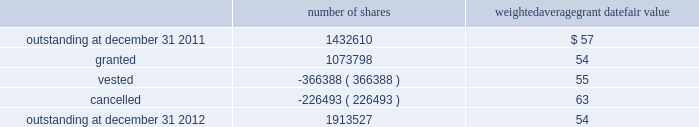The weighted average grant date fair value of options granted during 2012 , 2011 , and 2010 was $ 13 , $ 19 and $ 20 per share , respectively .
The total intrinsic value of options exercised during the years ended december 31 , 2012 , 2011 and 2010 , was $ 19.0 million , $ 4.2 million and $ 15.6 million , respectively .
In 2012 , the company granted 931340 shares of restricted class a common stock and 4048 shares of restricted stock units .
Restricted common stock and restricted stock units generally have a vesting period of 2 to 4 years .
The fair value related to these grants was $ 54.5 million , which is recognized as compensation expense on an accelerated basis over the vesting period .
Beginning with restricted stock grants in september 2010 , dividends are accrued on restricted class a common stock and restricted stock units and are paid once the restricted stock vests .
In 2012 , the company also granted 138410 performance shares .
The fair value related to these grants was $ 7.7 million , which is recognized as compensation expense on an accelerated and straight-lined basis over the vesting period .
The vesting of these shares is contingent on meeting stated performance or market conditions .
The table summarizes restricted stock , restricted stock units , and performance shares activity for 2012 : number of shares weighted average grant date fair value outstanding at december 31 , 2011 .
1432610 $ 57 .
Outstanding at december 31 , 2012 .
1913527 54 the total fair value of restricted stock , restricted stock units , and performance shares that vested during the years ended december 31 , 2012 , 2011 and 2010 , was $ 20.9 million , $ 11.6 million and $ 10.3 million , respectively .
Eligible employees may acquire shares of class a common stock using after-tax payroll deductions made during consecutive offering periods of approximately six months in duration .
Shares are purchased at the end of each offering period at a price of 90% ( 90 % ) of the closing price of the class a common stock as reported on the nasdaq global select market .
Compensation expense is recognized on the dates of purchase for the discount from the closing price .
In 2012 , 2011 and 2010 , a total of 27768 , 32085 and 21855 shares , respectively , of class a common stock were issued to participating employees .
These shares are subject to a six-month holding period .
Annual expense of $ 0.1 million , $ 0.2 million and $ 0.1 million for the purchase discount was recognized in 2012 , 2011 and 2010 , respectively .
Non-executive directors receive an annual award of class a common stock with a value equal to $ 75000 .
Non-executive directors may also elect to receive some or all of the cash portion of their annual stipend , up to $ 25000 , in shares of stock based on the closing price at the date of distribution .
As a result , 40260 , 40585 and 37350 shares of class a common stock were issued to non-executive directors during 2012 , 2011 and 2010 , respectively .
These shares are not subject to any vesting restrictions .
Expense of $ 2.2 million , $ 2.1 million and $ 2.4 million related to these stock-based payments was recognized for the years ended december 31 , 2012 , 2011 and 2010 , respectively .
19 .
Fair value measurements in general , the company uses quoted prices in active markets for identical assets to determine the fair value of marketable securities and equity investments .
Level 1 assets generally include u.s .
Treasury securities , equity securities listed in active markets , and investments in publicly traded mutual funds with quoted market prices .
If quoted prices are not available to determine fair value , the company uses other inputs that are directly observable .
Assets included in level 2 generally consist of asset- backed securities , municipal bonds , u.s .
Government agency securities and interest rate swap contracts .
Asset-backed securities , municipal bonds and u.s .
Government agency securities were measured at fair value based on matrix pricing using prices of similar securities with similar inputs such as maturity dates , interest rates and credit ratings .
The company determined the fair value of its interest rate swap contracts using standard valuation models with market-based observable inputs including forward and spot exchange rates and interest rate curves. .
What is the total value of cancelled shares , ( in millions ) ? 
Computations: ((226493 * 63) / 1000000)
Answer: 14.26906. 